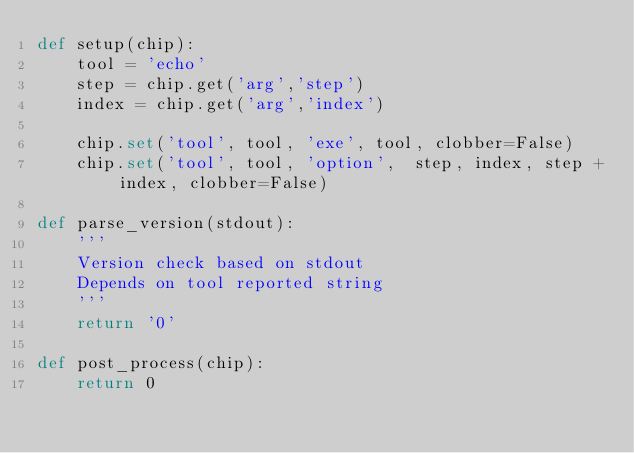Convert code to text. <code><loc_0><loc_0><loc_500><loc_500><_Python_>def setup(chip):
    tool = 'echo'
    step = chip.get('arg','step')
    index = chip.get('arg','index')

    chip.set('tool', tool, 'exe', tool, clobber=False)
    chip.set('tool', tool, 'option',  step, index, step + index, clobber=False)

def parse_version(stdout):
    '''
    Version check based on stdout
    Depends on tool reported string
    '''
    return '0'

def post_process(chip):
    return 0
</code> 